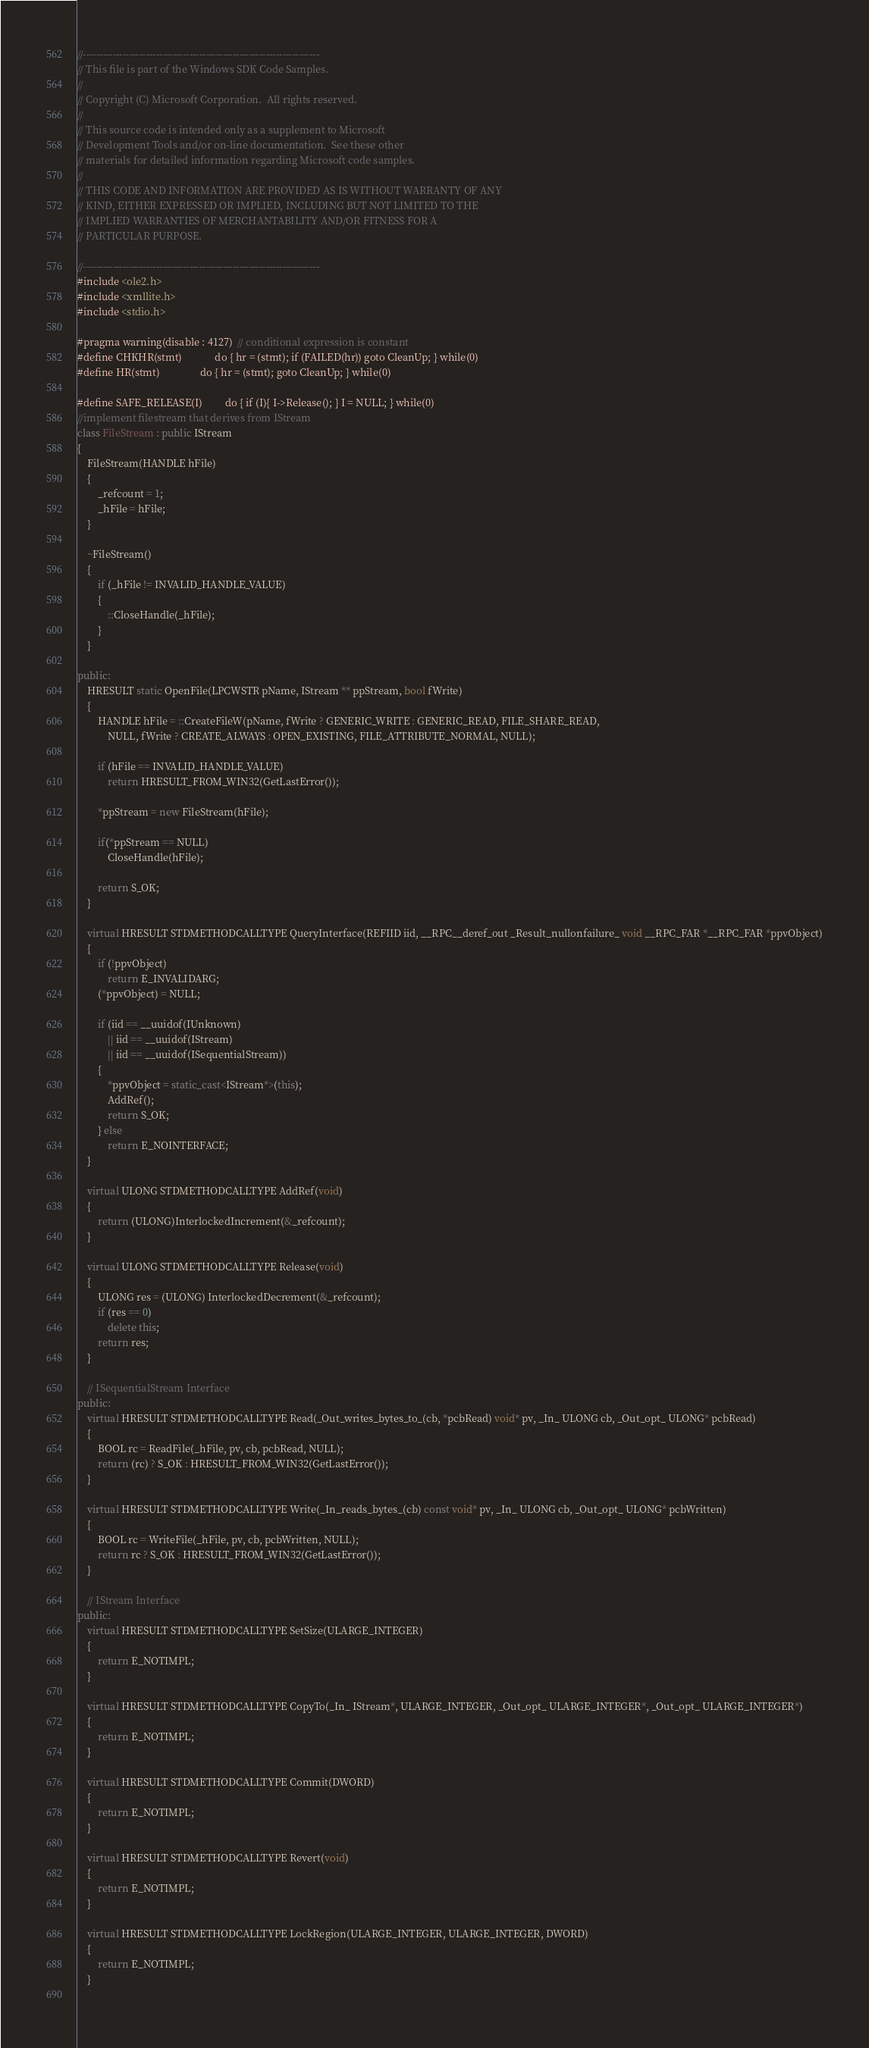Convert code to text. <code><loc_0><loc_0><loc_500><loc_500><_C++_>//-----------------------------------------------------------------------
// This file is part of the Windows SDK Code Samples.
// 
// Copyright (C) Microsoft Corporation.  All rights reserved.
// 
// This source code is intended only as a supplement to Microsoft
// Development Tools and/or on-line documentation.  See these other
// materials for detailed information regarding Microsoft code samples.
// 
// THIS CODE AND INFORMATION ARE PROVIDED AS IS WITHOUT WARRANTY OF ANY
// KIND, EITHER EXPRESSED OR IMPLIED, INCLUDING BUT NOT LIMITED TO THE
// IMPLIED WARRANTIES OF MERCHANTABILITY AND/OR FITNESS FOR A
// PARTICULAR PURPOSE.

//-----------------------------------------------------------------------
#include <ole2.h>
#include <xmllite.h>
#include <stdio.h>

#pragma warning(disable : 4127)  // conditional expression is constant
#define CHKHR(stmt)             do { hr = (stmt); if (FAILED(hr)) goto CleanUp; } while(0)
#define HR(stmt)                do { hr = (stmt); goto CleanUp; } while(0)

#define SAFE_RELEASE(I)         do { if (I){ I->Release(); } I = NULL; } while(0)
//implement filestream that derives from IStream
class FileStream : public IStream
{
    FileStream(HANDLE hFile) 
    {
        _refcount = 1;
        _hFile = hFile;
    }

    ~FileStream()
    {
        if (_hFile != INVALID_HANDLE_VALUE)
        {
            ::CloseHandle(_hFile);
        }
    }

public:
    HRESULT static OpenFile(LPCWSTR pName, IStream ** ppStream, bool fWrite)
    {
        HANDLE hFile = ::CreateFileW(pName, fWrite ? GENERIC_WRITE : GENERIC_READ, FILE_SHARE_READ,
            NULL, fWrite ? CREATE_ALWAYS : OPEN_EXISTING, FILE_ATTRIBUTE_NORMAL, NULL);

        if (hFile == INVALID_HANDLE_VALUE)
            return HRESULT_FROM_WIN32(GetLastError());
        
        *ppStream = new FileStream(hFile);
        
        if(*ppStream == NULL)
            CloseHandle(hFile);
            
        return S_OK;
    }

    virtual HRESULT STDMETHODCALLTYPE QueryInterface(REFIID iid, __RPC__deref_out _Result_nullonfailure_ void __RPC_FAR *__RPC_FAR *ppvObject)
    {
        if (!ppvObject)
            return E_INVALIDARG;
        (*ppvObject) = NULL;

        if (iid == __uuidof(IUnknown)
            || iid == __uuidof(IStream)
            || iid == __uuidof(ISequentialStream))
        {
            *ppvObject = static_cast<IStream*>(this);
            AddRef();
            return S_OK;
        } else
            return E_NOINTERFACE; 
    }

    virtual ULONG STDMETHODCALLTYPE AddRef(void) 
    { 
        return (ULONG)InterlockedIncrement(&_refcount); 
    }

    virtual ULONG STDMETHODCALLTYPE Release(void) 
    {
        ULONG res = (ULONG) InterlockedDecrement(&_refcount);
        if (res == 0) 
            delete this;
        return res;
    }

    // ISequentialStream Interface
public:
    virtual HRESULT STDMETHODCALLTYPE Read(_Out_writes_bytes_to_(cb, *pcbRead) void* pv, _In_ ULONG cb, _Out_opt_ ULONG* pcbRead)
    {
        BOOL rc = ReadFile(_hFile, pv, cb, pcbRead, NULL);
        return (rc) ? S_OK : HRESULT_FROM_WIN32(GetLastError());
    }

    virtual HRESULT STDMETHODCALLTYPE Write(_In_reads_bytes_(cb) const void* pv, _In_ ULONG cb, _Out_opt_ ULONG* pcbWritten)
    {
        BOOL rc = WriteFile(_hFile, pv, cb, pcbWritten, NULL);
        return rc ? S_OK : HRESULT_FROM_WIN32(GetLastError());
    }

    // IStream Interface
public:
    virtual HRESULT STDMETHODCALLTYPE SetSize(ULARGE_INTEGER)
    { 
        return E_NOTIMPL;   
    }
    
    virtual HRESULT STDMETHODCALLTYPE CopyTo(_In_ IStream*, ULARGE_INTEGER, _Out_opt_ ULARGE_INTEGER*, _Out_opt_ ULARGE_INTEGER*)
    { 
        return E_NOTIMPL;   
    }
    
    virtual HRESULT STDMETHODCALLTYPE Commit(DWORD)                                      
    { 
        return E_NOTIMPL;   
    }
    
    virtual HRESULT STDMETHODCALLTYPE Revert(void)                                       
    { 
        return E_NOTIMPL;   
    }
    
    virtual HRESULT STDMETHODCALLTYPE LockRegion(ULARGE_INTEGER, ULARGE_INTEGER, DWORD)              
    { 
        return E_NOTIMPL;   
    }
    </code> 